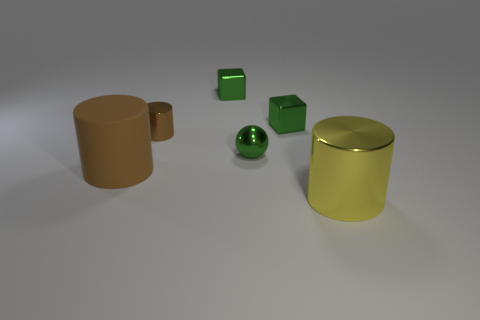Add 2 tiny shiny balls. How many objects exist? 8 Subtract all blocks. How many objects are left? 4 Subtract all small objects. Subtract all big yellow cylinders. How many objects are left? 1 Add 2 tiny green spheres. How many tiny green spheres are left? 3 Add 2 big rubber things. How many big rubber things exist? 3 Subtract 0 purple cylinders. How many objects are left? 6 